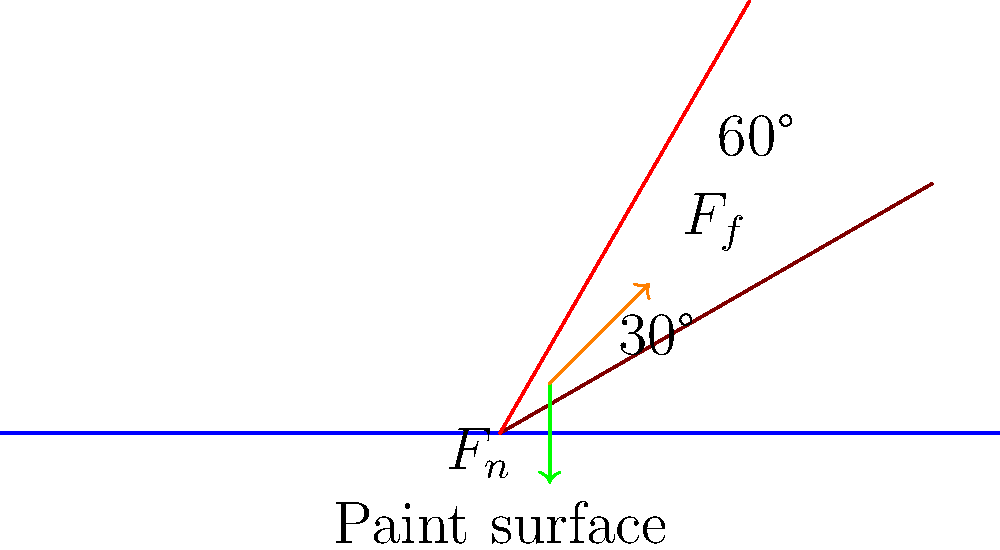Consider a paintbrush dipped in paint at two different angles: 30° and 60° from the horizontal paint surface. How does the angle of the paintbrush affect the normal force ($F_n$) and friction force ($F_f$) acting on the brush? Which angle would likely result in more paint being picked up by the brush? To understand the forces acting on the paintbrush, let's analyze the situation step-by-step:

1. Normal force ($F_n$):
   - The normal force is perpendicular to the paint surface.
   - As the angle increases, the component of the brush's weight perpendicular to the surface decreases.
   - Therefore, the normal force is greater at 30° than at 60°.

2. Friction force ($F_f$):
   - Friction force is parallel to the paint surface and opposes the motion of the brush.
   - It is proportional to the normal force: $F_f = \mu F_n$, where $\mu$ is the coefficient of friction.
   - Since the normal force is greater at 30°, the friction force is also greater at this angle.

3. Paint pickup:
   - More paint is likely to be picked up when there's greater contact between the brush and the paint surface.
   - At 30°, there's more surface area of the brush in contact with the paint.
   - The larger normal force at 30° also means more pressure on the paint, likely resulting in more paint adhering to the brush.

4. Angle comparison:
   - 30° angle: Higher normal force, higher friction force, more surface contact, more paint pickup.
   - 60° angle: Lower normal force, lower friction force, less surface contact, less paint pickup.

Therefore, the 30° angle would likely result in more paint being picked up by the brush due to the greater normal force, friction force, and surface contact with the paint.
Answer: 30° angle results in greater forces and more paint pickup. 